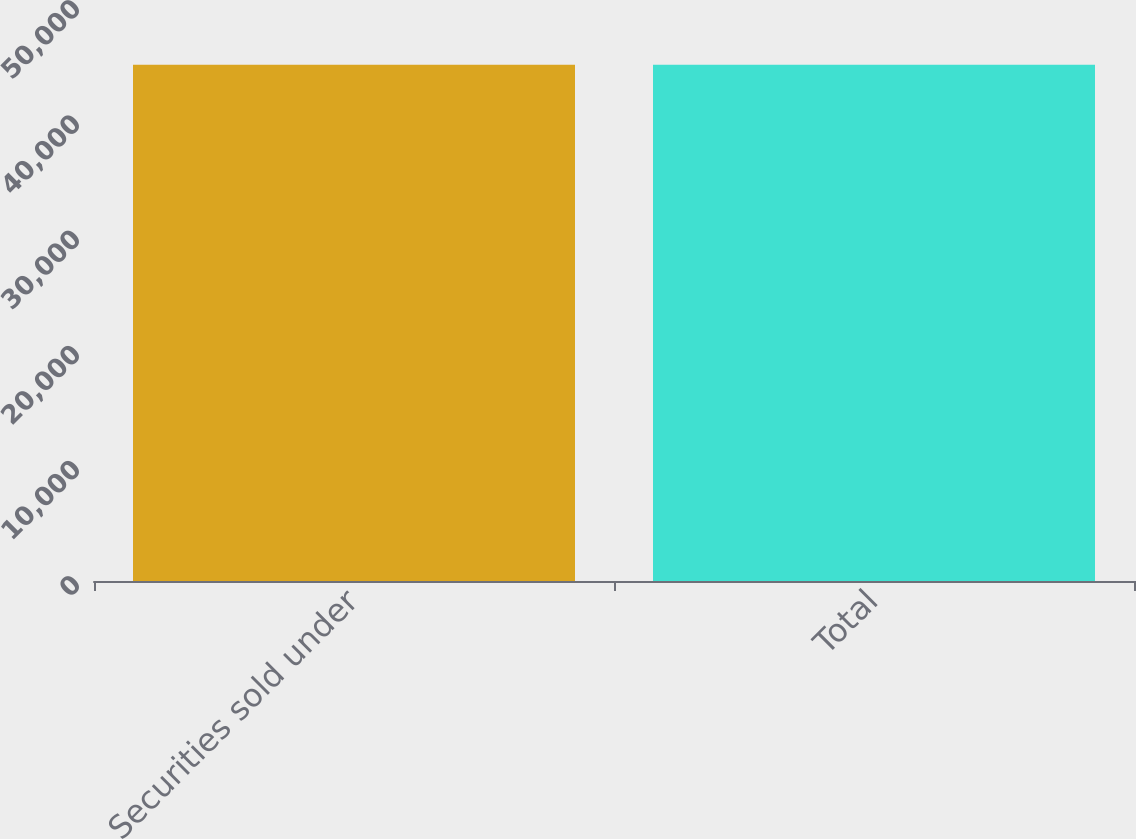Convert chart. <chart><loc_0><loc_0><loc_500><loc_500><bar_chart><fcel>Securities sold under<fcel>Total<nl><fcel>44811<fcel>44811.1<nl></chart> 